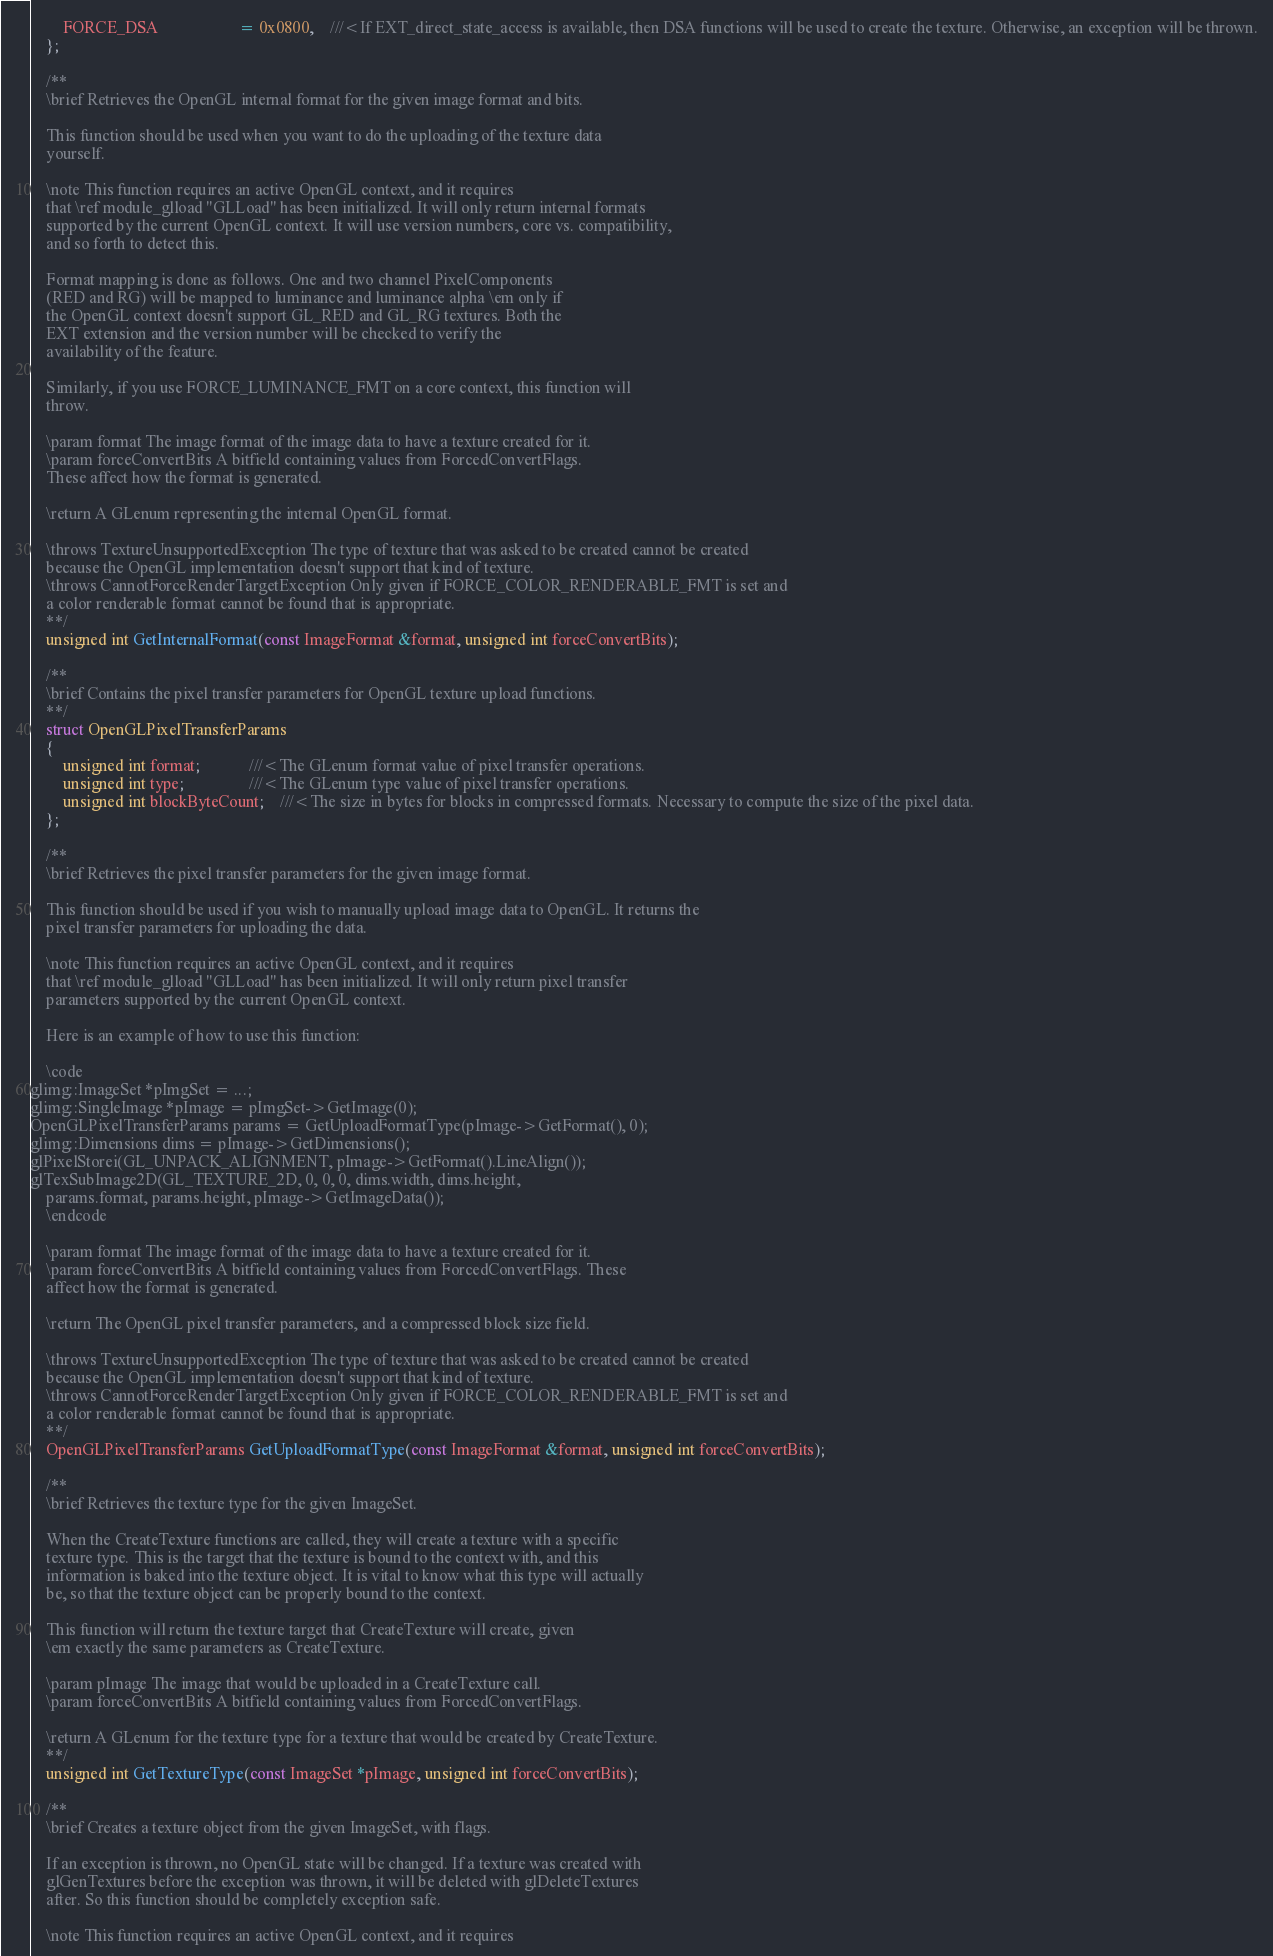Convert code to text. <code><loc_0><loc_0><loc_500><loc_500><_C_>		FORCE_DSA					= 0x0800,	///<If EXT_direct_state_access is available, then DSA functions will be used to create the texture. Otherwise, an exception will be thrown.
	};

	/**
	\brief Retrieves the OpenGL internal format for the given image format and bits.

	This function should be used when you want to do the uploading of the texture data
	yourself.
	
	\note This function requires an active OpenGL context, and it requires
	that \ref module_glload "GLLoad" has been initialized. It will only return internal formats
	supported by the current OpenGL context. It will use version numbers, core vs. compatibility,
	and so forth to detect this.
	
	Format mapping is done as follows. One and two channel PixelComponents
	(RED and RG) will be mapped to luminance and luminance alpha \em only if
	the OpenGL context doesn't support GL_RED and GL_RG textures. Both the
	EXT extension and the version number will be checked to verify the
	availability of the feature.
	
	Similarly, if you use FORCE_LUMINANCE_FMT on a core context, this function will
	throw.

	\param format The image format of the image data to have a texture created for it.
	\param forceConvertBits A bitfield containing values from ForcedConvertFlags.
	These affect how the format is generated.

	\return A GLenum representing the internal OpenGL format.

	\throws TextureUnsupportedException The type of texture that was asked to be created cannot be created
	because the OpenGL implementation doesn't support that kind of texture.
	\throws CannotForceRenderTargetException Only given if FORCE_COLOR_RENDERABLE_FMT is set and
	a color renderable format cannot be found that is appropriate.
	**/
	unsigned int GetInternalFormat(const ImageFormat &format, unsigned int forceConvertBits);

	/**
	\brief Contains the pixel transfer parameters for OpenGL texture upload functions.
	**/
	struct OpenGLPixelTransferParams
	{
		unsigned int format;			///<The GLenum format value of pixel transfer operations.
		unsigned int type;				///<The GLenum type value of pixel transfer operations.
		unsigned int blockByteCount;	///<The size in bytes for blocks in compressed formats. Necessary to compute the size of the pixel data.
	};

	/**
	\brief Retrieves the pixel transfer parameters for the given image format.

	This function should be used if you wish to manually upload image data to OpenGL. It returns the
	pixel transfer parameters for uploading the data.

	\note This function requires an active OpenGL context, and it requires
	that \ref module_glload "GLLoad" has been initialized. It will only return pixel transfer
	parameters supported by the current OpenGL context.

	Here is an example of how to use this function:

	\code
glimg::ImageSet *pImgSet = ...;
glimg::SingleImage *pImage = pImgSet->GetImage(0);
OpenGLPixelTransferParams params = GetUploadFormatType(pImage->GetFormat(), 0);
glimg::Dimensions dims = pImage->GetDimensions();
glPixelStorei(GL_UNPACK_ALIGNMENT, pImage->GetFormat().LineAlign());
glTexSubImage2D(GL_TEXTURE_2D, 0, 0, 0, dims.width, dims.height,
	params.format, params.height, pImage->GetImageData());
	\endcode

	\param format The image format of the image data to have a texture created for it.
	\param forceConvertBits A bitfield containing values from ForcedConvertFlags. These
	affect how the format is generated.

	\return The OpenGL pixel transfer parameters, and a compressed block size field.

	\throws TextureUnsupportedException The type of texture that was asked to be created cannot be created
	because the OpenGL implementation doesn't support that kind of texture.
	\throws CannotForceRenderTargetException Only given if FORCE_COLOR_RENDERABLE_FMT is set and
	a color renderable format cannot be found that is appropriate.
	**/
	OpenGLPixelTransferParams GetUploadFormatType(const ImageFormat &format, unsigned int forceConvertBits);

	/**
	\brief Retrieves the texture type for the given ImageSet.

	When the CreateTexture functions are called, they will create a texture with a specific
	texture type. This is the target that the texture is bound to the context with, and this
	information is baked into the texture object. It is vital to know what this type will actually
	be, so that the texture object can be properly bound to the context.

	This function will return the texture target that CreateTexture will create, given
	\em exactly the same parameters as CreateTexture.

	\param pImage The image that would be uploaded in a CreateTexture call.
	\param forceConvertBits A bitfield containing values from ForcedConvertFlags.

	\return A GLenum for the texture type for a texture that would be created by CreateTexture.
	**/
	unsigned int GetTextureType(const ImageSet *pImage, unsigned int forceConvertBits);

	/**
	\brief Creates a texture object from the given ImageSet, with flags.

	If an exception is thrown, no OpenGL state will be changed. If a texture was created with
	glGenTextures before the exception was thrown, it will be deleted with glDeleteTextures
	after. So this function should be completely exception safe.

	\note This function requires an active OpenGL context, and it requires</code> 